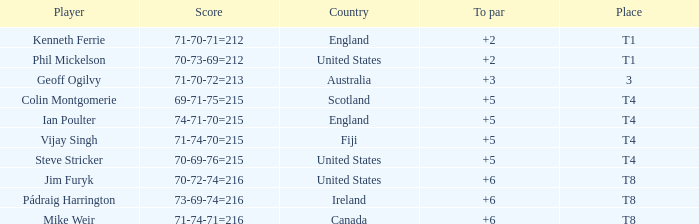What score above par did mike weir attain at its peak? 6.0. 